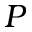Convert formula to latex. <formula><loc_0><loc_0><loc_500><loc_500>P</formula> 